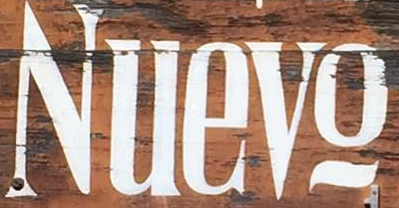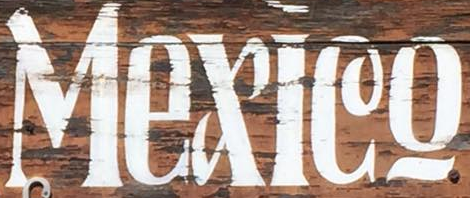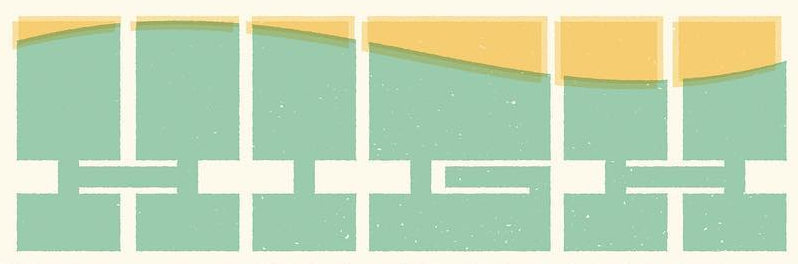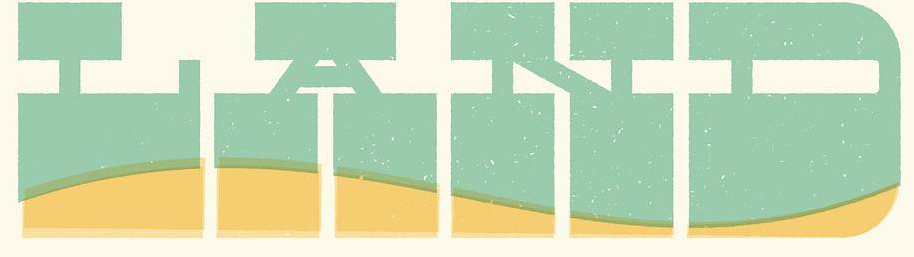What words are shown in these images in order, separated by a semicolon? Nuevo; Mexleo; HIGH; LAND 